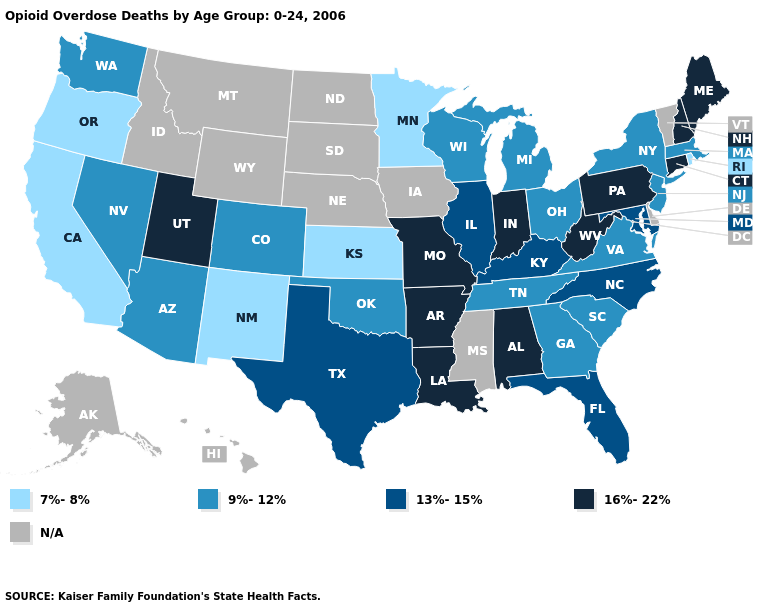Does Arizona have the lowest value in the West?
Short answer required. No. What is the value of Idaho?
Keep it brief. N/A. Name the states that have a value in the range 7%-8%?
Answer briefly. California, Kansas, Minnesota, New Mexico, Oregon, Rhode Island. What is the highest value in the Northeast ?
Quick response, please. 16%-22%. Name the states that have a value in the range N/A?
Write a very short answer. Alaska, Delaware, Hawaii, Idaho, Iowa, Mississippi, Montana, Nebraska, North Dakota, South Dakota, Vermont, Wyoming. What is the value of Alaska?
Keep it brief. N/A. What is the value of Delaware?
Short answer required. N/A. Name the states that have a value in the range 13%-15%?
Write a very short answer. Florida, Illinois, Kentucky, Maryland, North Carolina, Texas. Among the states that border Texas , does New Mexico have the lowest value?
Be succinct. Yes. Name the states that have a value in the range 13%-15%?
Keep it brief. Florida, Illinois, Kentucky, Maryland, North Carolina, Texas. Name the states that have a value in the range N/A?
Give a very brief answer. Alaska, Delaware, Hawaii, Idaho, Iowa, Mississippi, Montana, Nebraska, North Dakota, South Dakota, Vermont, Wyoming. Name the states that have a value in the range 16%-22%?
Short answer required. Alabama, Arkansas, Connecticut, Indiana, Louisiana, Maine, Missouri, New Hampshire, Pennsylvania, Utah, West Virginia. Does Nevada have the lowest value in the USA?
Short answer required. No. Which states have the highest value in the USA?
Write a very short answer. Alabama, Arkansas, Connecticut, Indiana, Louisiana, Maine, Missouri, New Hampshire, Pennsylvania, Utah, West Virginia. 